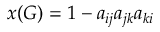<formula> <loc_0><loc_0><loc_500><loc_500>x ( G ) = 1 - a _ { i j } a _ { j k } a _ { k i }</formula> 